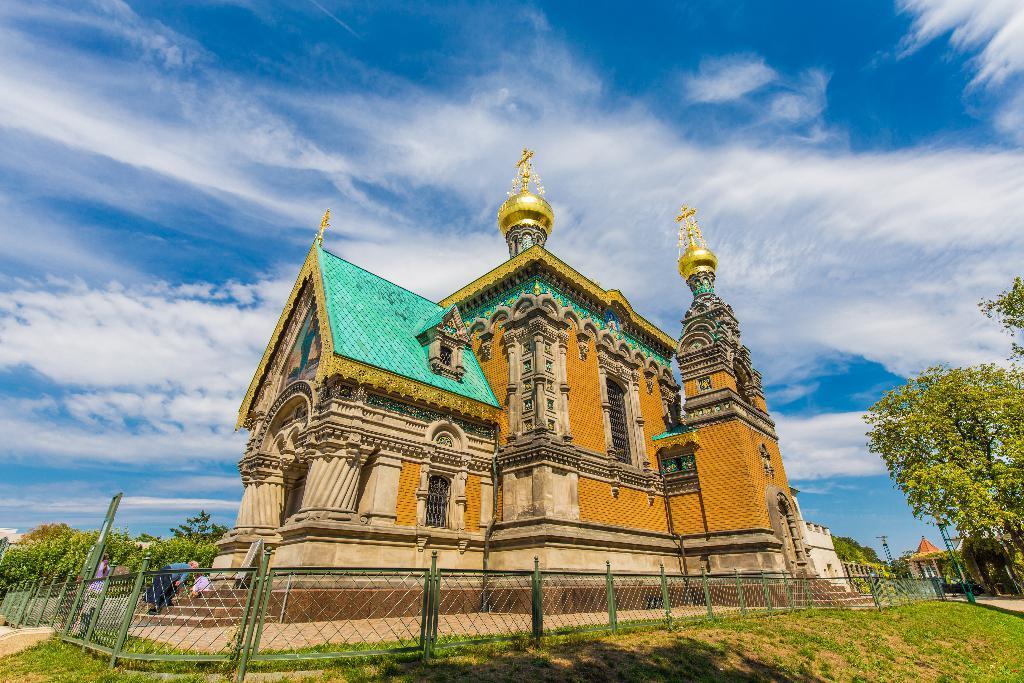How would you summarize this image in a sentence or two? This image is taken outdoors. At the top of the image there is the sky with clouds. At the bottom of the image there is a ground with grass on it. In the middle of the image there is a temple with walls, windows, a door, pillars, carvings, sculptures and a roof. There is a mesh. There are a few people standing on the stairs. In the background there are many trees. On the right side of the image there are a few trees. There is a stall and there is a tower. 